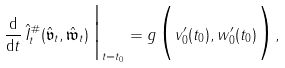<formula> <loc_0><loc_0><loc_500><loc_500>\frac { \mathrm d } { \mathrm d t } \, \hat { I } ^ { \# } _ { t } ( \hat { \mathfrak v } _ { t } , \hat { \mathfrak w } _ { t } ) \, \Big | _ { t = t _ { 0 } } = g \Big ( v _ { 0 } ^ { \prime } ( t _ { 0 } ) , w _ { 0 } ^ { \prime } ( t _ { 0 } ) \Big ) ,</formula> 